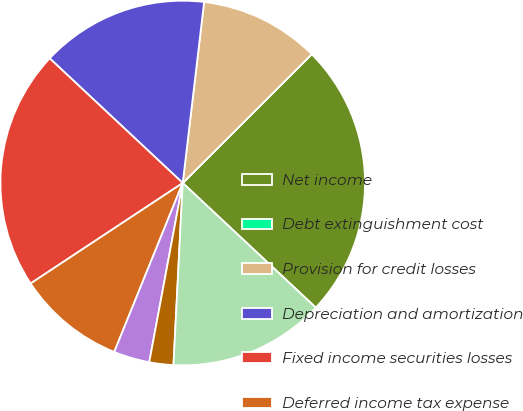Convert chart. <chart><loc_0><loc_0><loc_500><loc_500><pie_chart><fcel>Net income<fcel>Debt extinguishment cost<fcel>Provision for credit losses<fcel>Depreciation and amortization<fcel>Fixed income securities losses<fcel>Deferred income tax expense<fcel>Net decrease (increase) in<fcel>Change in other liabilities<fcel>Change in other assets<nl><fcel>24.46%<fcel>0.0%<fcel>10.64%<fcel>14.89%<fcel>21.27%<fcel>9.58%<fcel>3.19%<fcel>2.13%<fcel>13.83%<nl></chart> 